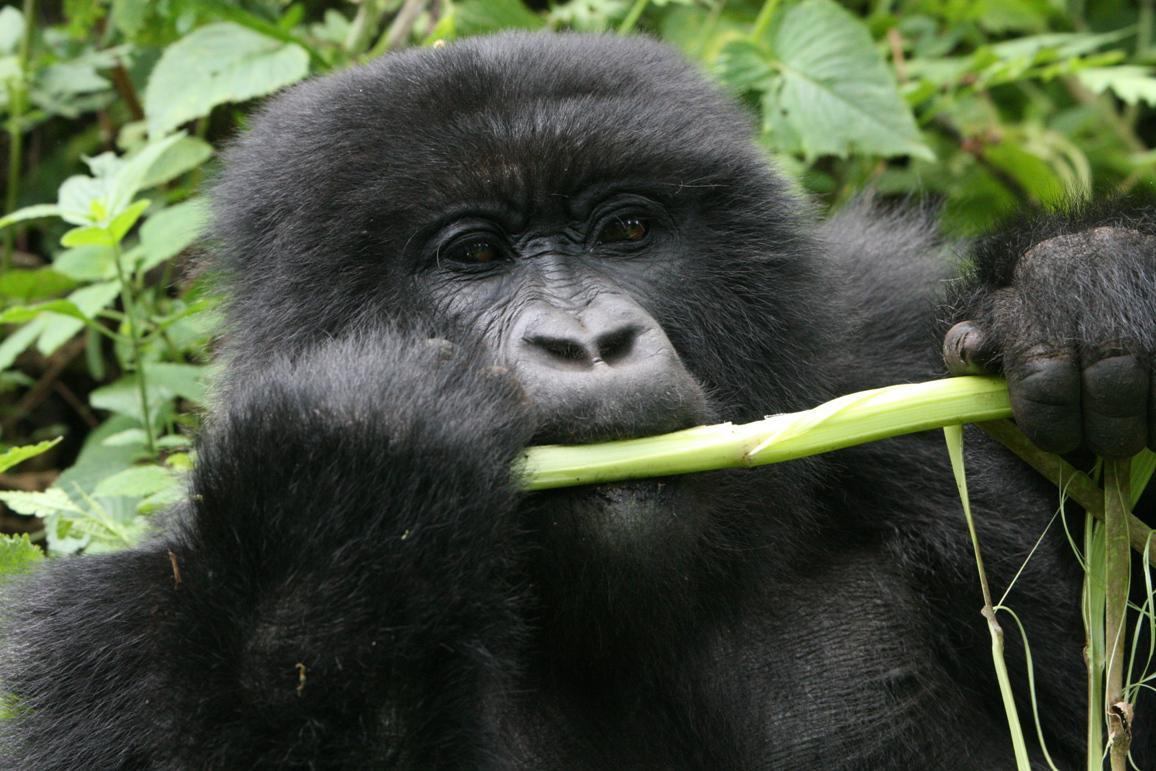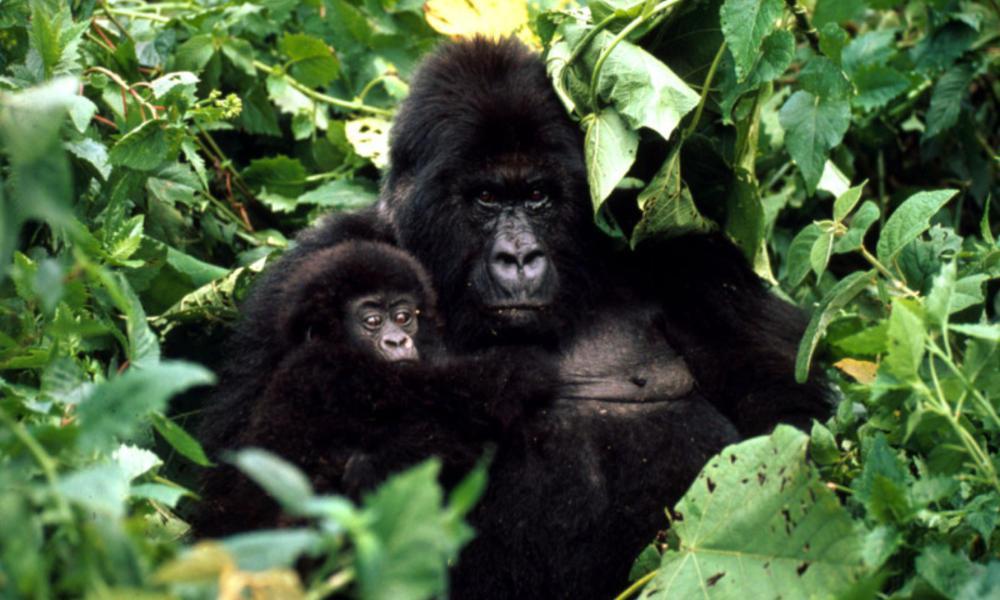The first image is the image on the left, the second image is the image on the right. For the images displayed, is the sentence "At least one of the animals in the group is not eating." factually correct? Answer yes or no. Yes. The first image is the image on the left, the second image is the image on the right. Considering the images on both sides, is "The right image includes twice the number of gorillas as the left image." valid? Answer yes or no. Yes. 